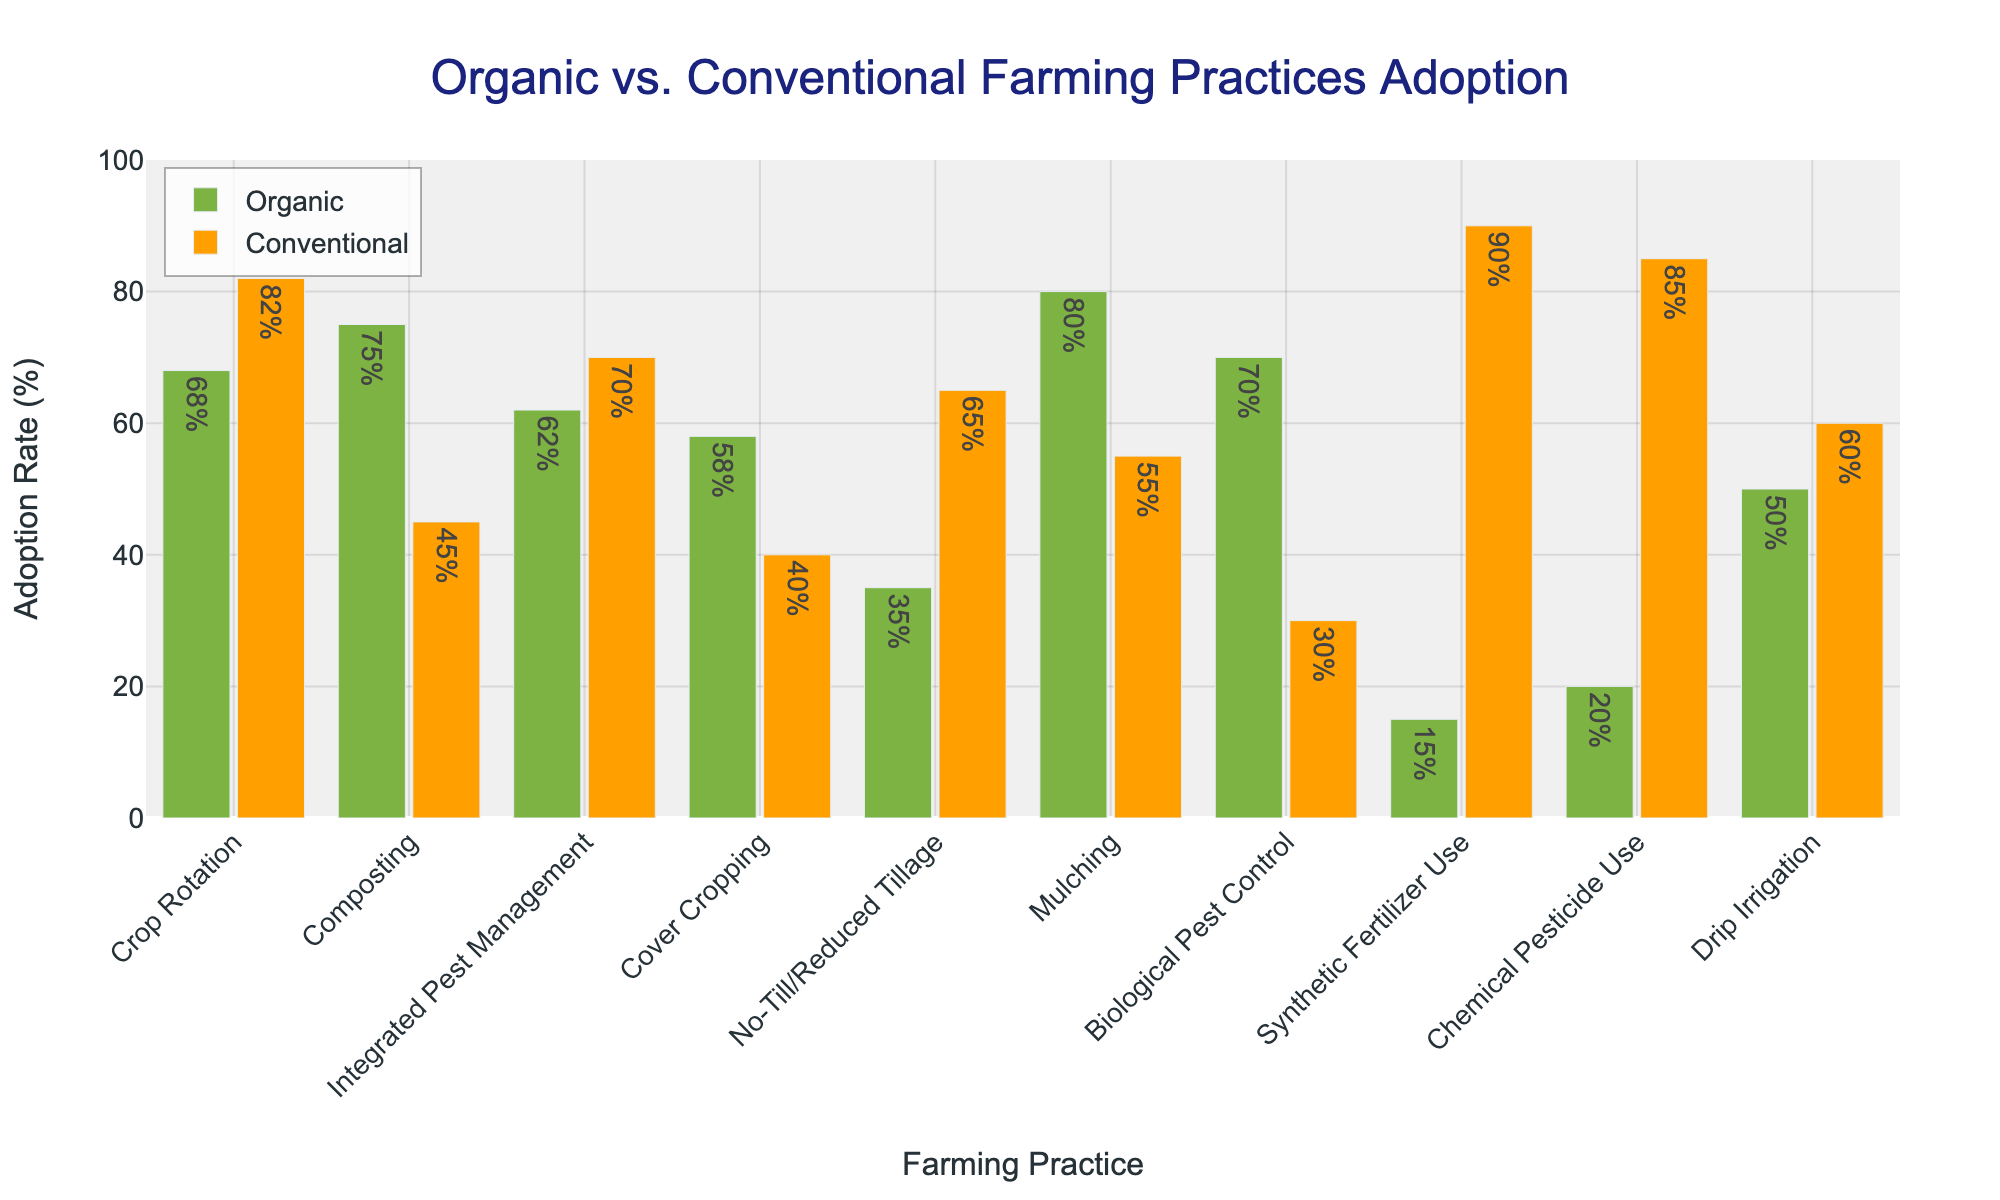Which farming practice has the highest adoption rate in organic practices? Look at the green bars representing organic adoption rates. The tallest green bar indicates the highest adoption rate, which is Mulching at 80%.
Answer: Mulching Which farming practice has the lowest adoption rate in conventional practices? Look at the orange bars representing conventional adoption rates. The shortest orange bar indicates the lowest adoption rate, which is Biological Pest Control at 30%.
Answer: Biological Pest Control What is the difference in adoption rates between organic and conventional practices for Crop Rotation? The organic adoption rate for Crop Rotation is 68%, and the conventional adoption rate is 82%. The difference is 82% - 68% = 14%.
Answer: 14% Which farming practices have a higher adoption rate in organic practices compared to conventional practices? Compare the heights of the green bars (organic) with the corresponding orange bars (conventional) to see which ones are higher for organic. These practices include Composting, Cover Cropping, Mulching, and Biological Pest Control.
Answer: Composting, Cover Cropping, Mulching, Biological Pest Control What is the average adoption rate of organic practices across all farming practices? Sum the organic adoption rates for all practices and divide by the number of practices (10). So, (68% + 75% + 62% + 58% + 35% + 80% + 70% + 15% + 20% + 50%) / 10 = 533% / 10 = 53.3%.
Answer: 53.3% Among the practices where organic adoption is higher, which has the greatest difference from conventional adoption? Identify the practices where the green bars are taller than the orange bars, then calculate the differences. Compare those differences to find the greatest one. For Composting (75%-45%=30%), Cover Cropping (58%-40%=18%), Mulching (80%-55%=25%), Biological Pest Control (70%-30%=40%). The greatest is Biological Pest Control at 40%.
Answer: Biological Pest Control Is there any farming practice where the adoption rate is the same for both organic and conventional practices? Look at the figure to see if there is any set of bars (one green, one orange) of equal height. There are no bars of the same height, indicating no practice has equal adoption rates for organic and conventional methods.
Answer: No What is the combined total adoption rate of organic and conventional practices for Integrated Pest Management? The organic adoption rate is 62% and the conventional adoption rate is 70%. The combined total is 62% + 70% = 132%.
Answer: 132% Which farming practice shows the biggest visual disparity in adoption rates when comparing organic to conventional methods? Identify the bars with the most noticeable height difference between green (organic) and orange (conventional). Synthetic Fertilizer Use (15% organic vs 90% conventional) shows the biggest disparity.
Answer: Synthetic Fertilizer Use What is the ratio of the adoption rate of organic to conventional practices for No-Till/Reduced Tillage? The organic adoption rate is 35%, and the conventional adoption rate is 65%. The ratio is 35 / 65 = 0.538.
Answer: 0.538 